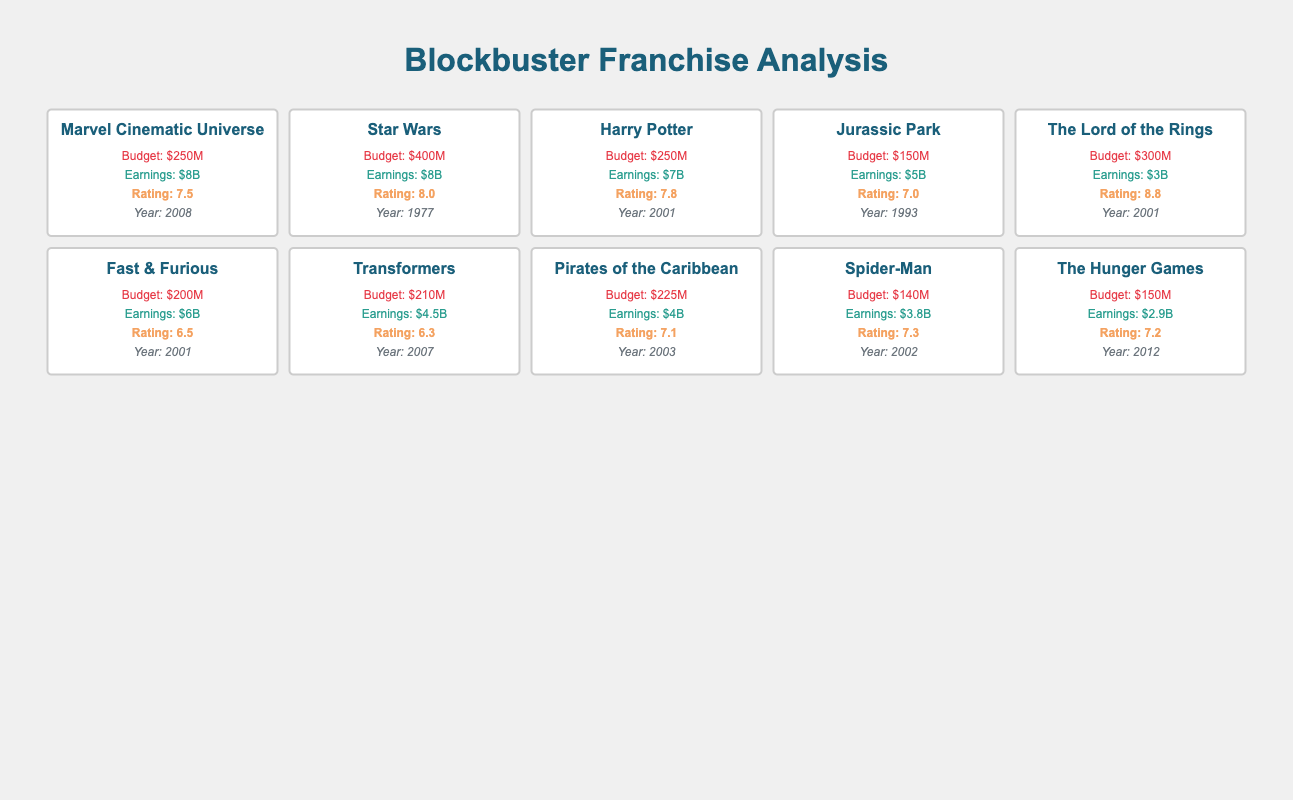What is the production budget for the Star Wars franchise? The table clearly shows that the production budget for the Star Wars franchise is listed under the budget section, noting a value of $400M.
Answer: $400M Which franchise has the highest box office earnings? By reviewing the box office earnings in the table, the Marvel Cinematic Universe and Star Wars franchises both have earnings of $8B, which appears to be the highest compared to others.
Answer: Marvel Cinematic Universe and Star Wars What is the difference in box office earnings between the Harry Potter franchise and the The Lord of the Rings franchise? The Harry Potter franchise earned $7B, while The Lord of the Rings earned $3B. The difference is calculated as $7B - $3B = $4B.
Answer: $4B Is the average rating of the Fast & Furious franchise greater than 7? The average rating for Fast & Furious is listed in the table as 6.5, which is less than 7. Thus, the statement is false.
Answer: No Which franchise has the lowest production budget and what is that budget? Looking at the production budgets, Jurassic Park has the lowest budget at $150M, evident in the corresponding row of the table.
Answer: $150M Calculate the average production budget of all franchises. The production budgets are: $250M, $400M, $250M, $150M, $300M, $200M, $210M, $225M, $140M, and $150M. Summing these gives $2,375M, and dividing by 10 (the number of franchises) results in an average production budget of $237.5M.
Answer: $237.5M Is the box office earning of Pirates of the Caribbean higher than that of Transformers? The box office earnings are $4B for Pirates of the Caribbean and $4.5B for Transformers. Since $4B is less than $4.5B, the answer is false.
Answer: No Which franchise released in 2001 has the highest box office earnings? In 2001, the franchises that released include Harry Potter, The Lord of the Rings, and Fast & Furious. Their respective box office earnings are $7B, $3B, and $6B. Harry Potter has the highest earnings of $7B among those released in that year.
Answer: Harry Potter What is the median average rating of the franchises listed? The average ratings are: 7.5, 8.0, 7.8, 7.0, 8.8, 6.5, 6.3, 7.1, 7.3, and 7.2. Sorting these ratings gives 6.3, 6.5, 7.0, 7.1, 7.2, 7.3, 7.5, 7.8, 8.0, 8.8. The median (middle value) is the average of 7.2 and 7.3, which calculates to (7.2 + 7.3) / 2 = 7.25.
Answer: 7.25 